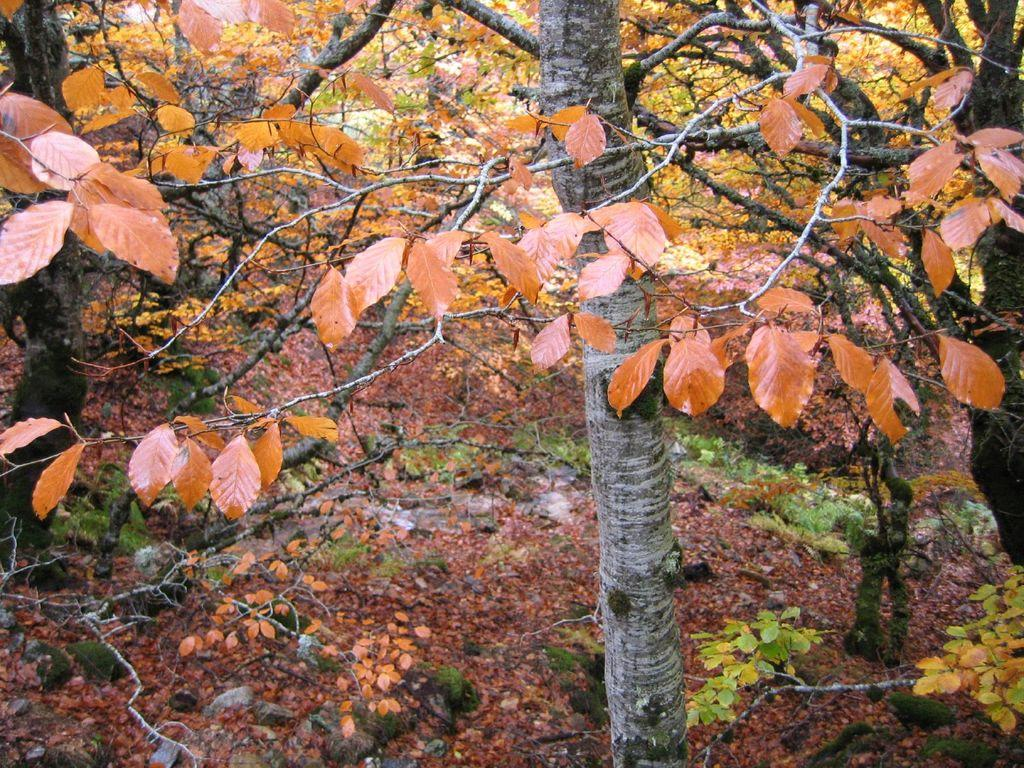What type of vegetation can be seen in the image? There are trees in the image. What colors are the leaves on the trees? The leaves on the trees have various colors, including yellow, green, orange, and brown. What type of bread can be seen hanging from the branches of the trees in the image? There is no bread present in the image; it features trees with leaves of various colors. 